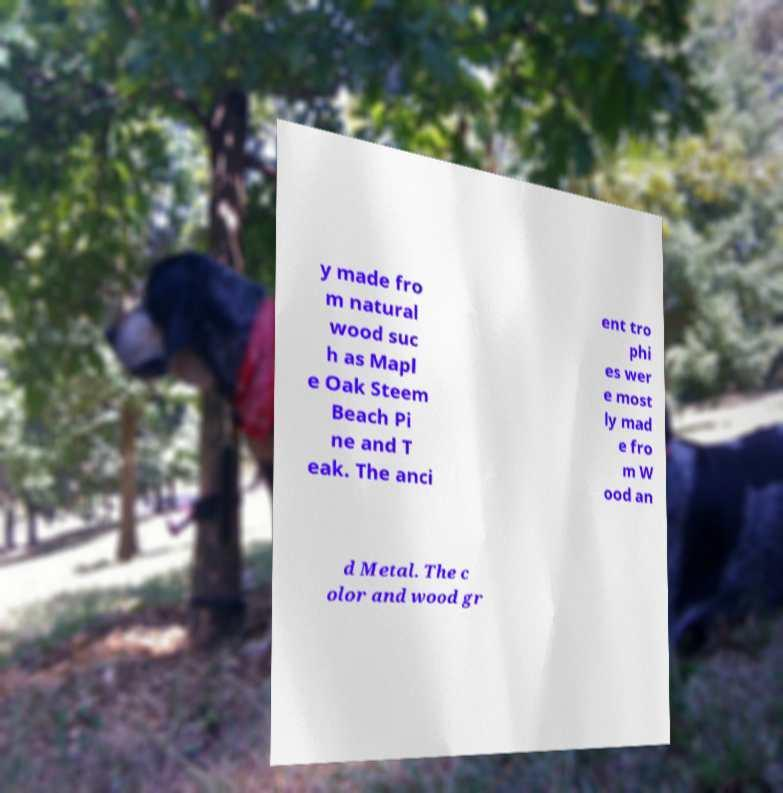Could you assist in decoding the text presented in this image and type it out clearly? y made fro m natural wood suc h as Mapl e Oak Steem Beach Pi ne and T eak. The anci ent tro phi es wer e most ly mad e fro m W ood an d Metal. The c olor and wood gr 